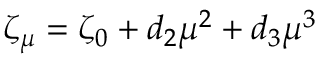Convert formula to latex. <formula><loc_0><loc_0><loc_500><loc_500>\zeta _ { \mu } = \zeta _ { 0 } + d _ { 2 } \mu ^ { 2 } + d _ { 3 } \mu ^ { 3 }</formula> 